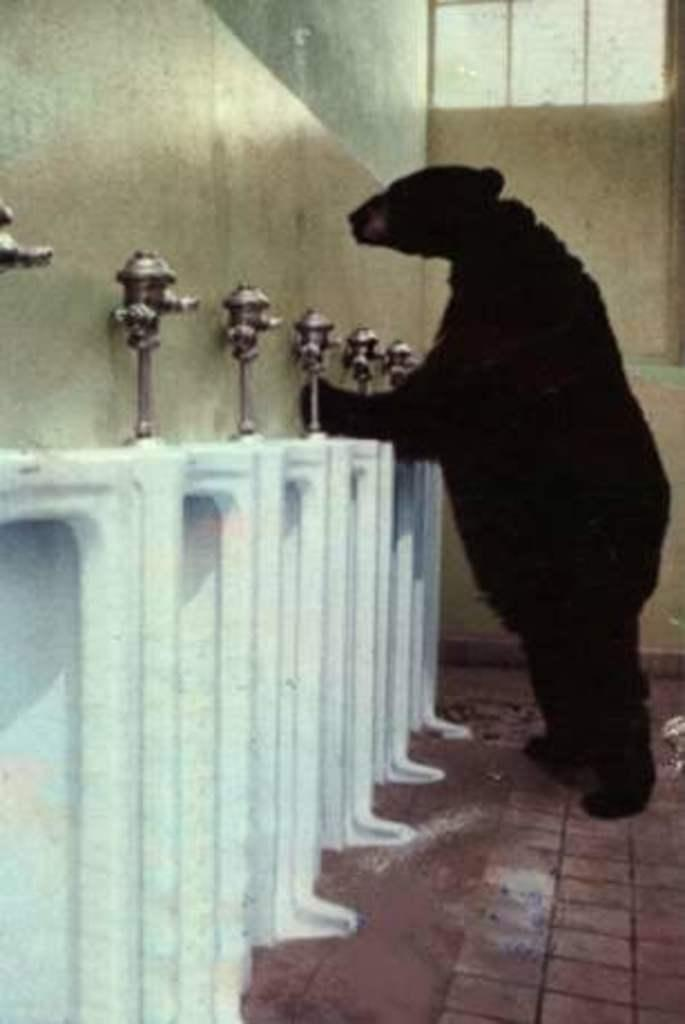What type of animal is in the image? There is a bear in the image. What color is the bear? The bear is black in color. What is the bear standing in front of? The bear is standing in front of a white object. Are there any other objects near the bear? Yes, there are other objects beside the bear. What type of competition is the bear participating in within the image? There is no competition present in the image; it simply shows a black bear standing in front of a white object. Is there any fire visible in the image? No, there is no fire present in the image. 